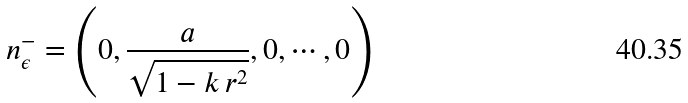<formula> <loc_0><loc_0><loc_500><loc_500>n _ { \epsilon } ^ { - } = \left ( 0 , \frac { a } { \sqrt { 1 - k \, r ^ { 2 } } } , 0 , \cdots , 0 \right )</formula> 